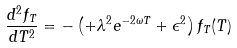Convert formula to latex. <formula><loc_0><loc_0><loc_500><loc_500>\frac { d ^ { 2 } f _ { T } } { d T ^ { 2 } } = - \left ( + \lambda ^ { 2 } e ^ { - 2 \omega T } + \epsilon ^ { 2 } \right ) f _ { T } ( T )</formula> 